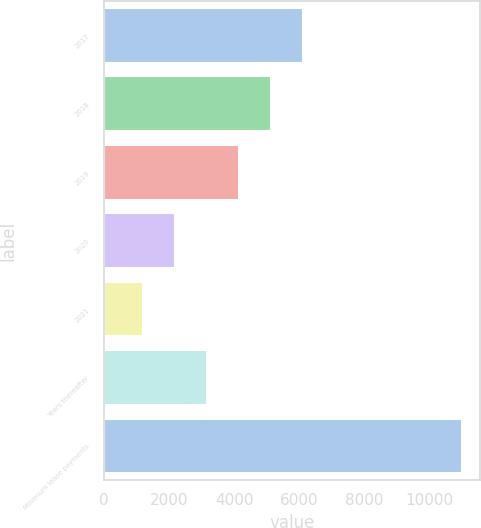Convert chart. <chart><loc_0><loc_0><loc_500><loc_500><bar_chart><fcel>2017<fcel>2018<fcel>2019<fcel>2020<fcel>2021<fcel>Years thereafter<fcel>Minimum lease payments<nl><fcel>6099<fcel>5122.8<fcel>4146.6<fcel>2194.2<fcel>1218<fcel>3170.4<fcel>10980<nl></chart> 